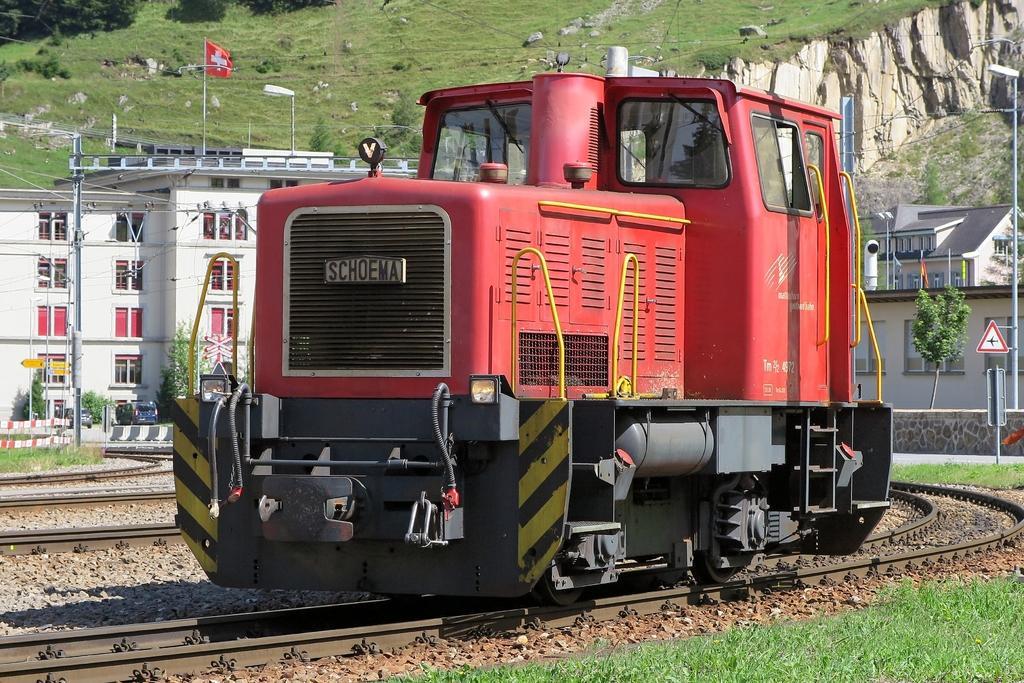In one or two sentences, can you explain what this image depicts? In the center of the image we can see a train. In the background of the image we can see the buildings, windows, poles, flag, lights, sign boards, trees, hills, grass, vehicles, barricades. At the bottom of the image we can see the railway tracks, stones, grass. 